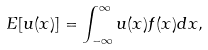Convert formula to latex. <formula><loc_0><loc_0><loc_500><loc_500>E [ u ( x ) ] = \int _ { - \infty } ^ { \infty } u ( x ) f ( x ) d x ,</formula> 